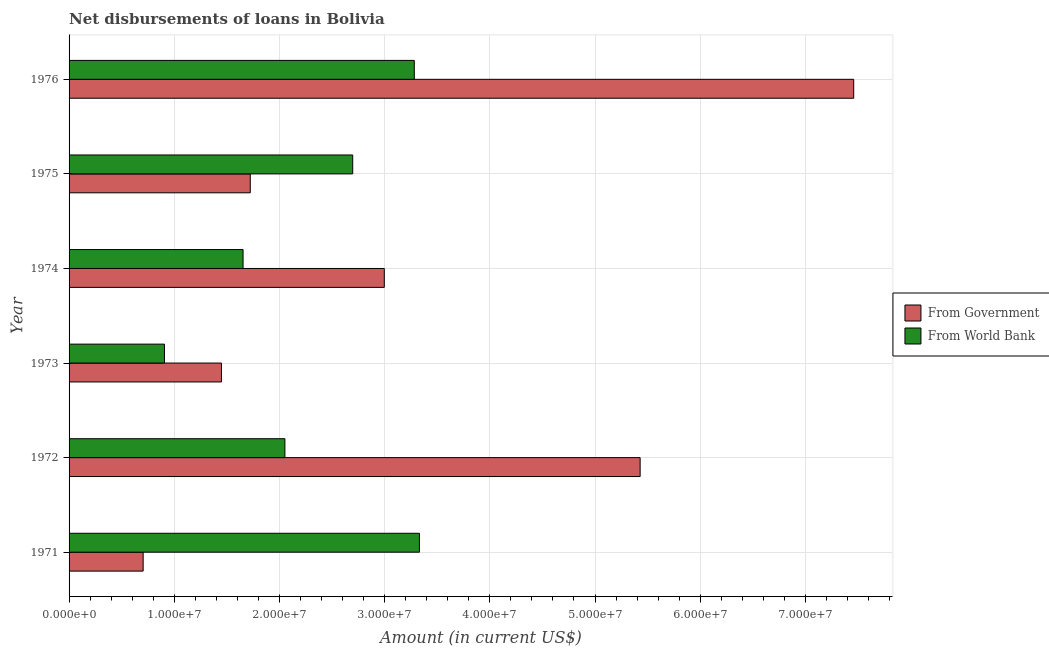How many groups of bars are there?
Make the answer very short. 6. How many bars are there on the 2nd tick from the bottom?
Your answer should be very brief. 2. What is the label of the 4th group of bars from the top?
Make the answer very short. 1973. In how many cases, is the number of bars for a given year not equal to the number of legend labels?
Your response must be concise. 0. What is the net disbursements of loan from world bank in 1973?
Your answer should be very brief. 9.07e+06. Across all years, what is the maximum net disbursements of loan from world bank?
Your answer should be very brief. 3.33e+07. Across all years, what is the minimum net disbursements of loan from world bank?
Keep it short and to the point. 9.07e+06. In which year was the net disbursements of loan from government maximum?
Provide a short and direct response. 1976. In which year was the net disbursements of loan from government minimum?
Provide a short and direct response. 1971. What is the total net disbursements of loan from world bank in the graph?
Give a very brief answer. 1.39e+08. What is the difference between the net disbursements of loan from world bank in 1973 and that in 1974?
Give a very brief answer. -7.47e+06. What is the difference between the net disbursements of loan from government in 1972 and the net disbursements of loan from world bank in 1971?
Keep it short and to the point. 2.10e+07. What is the average net disbursements of loan from world bank per year?
Your response must be concise. 2.32e+07. In the year 1975, what is the difference between the net disbursements of loan from world bank and net disbursements of loan from government?
Keep it short and to the point. 9.74e+06. In how many years, is the net disbursements of loan from government greater than 6000000 US$?
Make the answer very short. 6. What is the ratio of the net disbursements of loan from government in 1971 to that in 1972?
Make the answer very short. 0.13. Is the net disbursements of loan from world bank in 1971 less than that in 1974?
Offer a very short reply. No. Is the difference between the net disbursements of loan from world bank in 1973 and 1976 greater than the difference between the net disbursements of loan from government in 1973 and 1976?
Make the answer very short. Yes. What is the difference between the highest and the second highest net disbursements of loan from world bank?
Give a very brief answer. 4.87e+05. What is the difference between the highest and the lowest net disbursements of loan from world bank?
Your answer should be very brief. 2.42e+07. In how many years, is the net disbursements of loan from government greater than the average net disbursements of loan from government taken over all years?
Your response must be concise. 2. Is the sum of the net disbursements of loan from government in 1971 and 1973 greater than the maximum net disbursements of loan from world bank across all years?
Provide a succinct answer. No. What does the 2nd bar from the top in 1971 represents?
Offer a terse response. From Government. What does the 1st bar from the bottom in 1976 represents?
Keep it short and to the point. From Government. How many bars are there?
Provide a succinct answer. 12. Are all the bars in the graph horizontal?
Keep it short and to the point. Yes. What is the difference between two consecutive major ticks on the X-axis?
Your response must be concise. 1.00e+07. Are the values on the major ticks of X-axis written in scientific E-notation?
Provide a short and direct response. Yes. Where does the legend appear in the graph?
Provide a short and direct response. Center right. How many legend labels are there?
Offer a very short reply. 2. What is the title of the graph?
Your response must be concise. Net disbursements of loans in Bolivia. What is the Amount (in current US$) of From Government in 1971?
Your answer should be very brief. 7.04e+06. What is the Amount (in current US$) of From World Bank in 1971?
Offer a very short reply. 3.33e+07. What is the Amount (in current US$) in From Government in 1972?
Provide a succinct answer. 5.43e+07. What is the Amount (in current US$) in From World Bank in 1972?
Ensure brevity in your answer.  2.05e+07. What is the Amount (in current US$) of From Government in 1973?
Your response must be concise. 1.45e+07. What is the Amount (in current US$) in From World Bank in 1973?
Your response must be concise. 9.07e+06. What is the Amount (in current US$) in From Government in 1974?
Your answer should be compact. 3.00e+07. What is the Amount (in current US$) in From World Bank in 1974?
Provide a succinct answer. 1.65e+07. What is the Amount (in current US$) of From Government in 1975?
Provide a short and direct response. 1.72e+07. What is the Amount (in current US$) of From World Bank in 1975?
Make the answer very short. 2.70e+07. What is the Amount (in current US$) of From Government in 1976?
Keep it short and to the point. 7.46e+07. What is the Amount (in current US$) of From World Bank in 1976?
Ensure brevity in your answer.  3.28e+07. Across all years, what is the maximum Amount (in current US$) of From Government?
Keep it short and to the point. 7.46e+07. Across all years, what is the maximum Amount (in current US$) in From World Bank?
Give a very brief answer. 3.33e+07. Across all years, what is the minimum Amount (in current US$) of From Government?
Offer a terse response. 7.04e+06. Across all years, what is the minimum Amount (in current US$) of From World Bank?
Your answer should be compact. 9.07e+06. What is the total Amount (in current US$) in From Government in the graph?
Keep it short and to the point. 1.98e+08. What is the total Amount (in current US$) in From World Bank in the graph?
Keep it short and to the point. 1.39e+08. What is the difference between the Amount (in current US$) of From Government in 1971 and that in 1972?
Make the answer very short. -4.72e+07. What is the difference between the Amount (in current US$) in From World Bank in 1971 and that in 1972?
Make the answer very short. 1.28e+07. What is the difference between the Amount (in current US$) in From Government in 1971 and that in 1973?
Offer a terse response. -7.44e+06. What is the difference between the Amount (in current US$) in From World Bank in 1971 and that in 1973?
Your response must be concise. 2.42e+07. What is the difference between the Amount (in current US$) in From Government in 1971 and that in 1974?
Your answer should be compact. -2.29e+07. What is the difference between the Amount (in current US$) of From World Bank in 1971 and that in 1974?
Provide a succinct answer. 1.68e+07. What is the difference between the Amount (in current US$) in From Government in 1971 and that in 1975?
Ensure brevity in your answer.  -1.02e+07. What is the difference between the Amount (in current US$) in From World Bank in 1971 and that in 1975?
Ensure brevity in your answer.  6.34e+06. What is the difference between the Amount (in current US$) in From Government in 1971 and that in 1976?
Provide a succinct answer. -6.76e+07. What is the difference between the Amount (in current US$) in From World Bank in 1971 and that in 1976?
Offer a terse response. 4.87e+05. What is the difference between the Amount (in current US$) of From Government in 1972 and that in 1973?
Provide a short and direct response. 3.98e+07. What is the difference between the Amount (in current US$) in From World Bank in 1972 and that in 1973?
Your answer should be compact. 1.14e+07. What is the difference between the Amount (in current US$) of From Government in 1972 and that in 1974?
Make the answer very short. 2.43e+07. What is the difference between the Amount (in current US$) of From World Bank in 1972 and that in 1974?
Your answer should be compact. 3.98e+06. What is the difference between the Amount (in current US$) of From Government in 1972 and that in 1975?
Provide a short and direct response. 3.71e+07. What is the difference between the Amount (in current US$) in From World Bank in 1972 and that in 1975?
Make the answer very short. -6.45e+06. What is the difference between the Amount (in current US$) in From Government in 1972 and that in 1976?
Ensure brevity in your answer.  -2.03e+07. What is the difference between the Amount (in current US$) of From World Bank in 1972 and that in 1976?
Make the answer very short. -1.23e+07. What is the difference between the Amount (in current US$) of From Government in 1973 and that in 1974?
Your answer should be compact. -1.55e+07. What is the difference between the Amount (in current US$) in From World Bank in 1973 and that in 1974?
Offer a terse response. -7.47e+06. What is the difference between the Amount (in current US$) in From Government in 1973 and that in 1975?
Your answer should be very brief. -2.74e+06. What is the difference between the Amount (in current US$) in From World Bank in 1973 and that in 1975?
Offer a terse response. -1.79e+07. What is the difference between the Amount (in current US$) of From Government in 1973 and that in 1976?
Your answer should be very brief. -6.01e+07. What is the difference between the Amount (in current US$) of From World Bank in 1973 and that in 1976?
Ensure brevity in your answer.  -2.38e+07. What is the difference between the Amount (in current US$) in From Government in 1974 and that in 1975?
Make the answer very short. 1.27e+07. What is the difference between the Amount (in current US$) in From World Bank in 1974 and that in 1975?
Keep it short and to the point. -1.04e+07. What is the difference between the Amount (in current US$) in From Government in 1974 and that in 1976?
Offer a very short reply. -4.46e+07. What is the difference between the Amount (in current US$) of From World Bank in 1974 and that in 1976?
Your answer should be very brief. -1.63e+07. What is the difference between the Amount (in current US$) in From Government in 1975 and that in 1976?
Offer a terse response. -5.74e+07. What is the difference between the Amount (in current US$) in From World Bank in 1975 and that in 1976?
Your answer should be compact. -5.85e+06. What is the difference between the Amount (in current US$) of From Government in 1971 and the Amount (in current US$) of From World Bank in 1972?
Offer a very short reply. -1.35e+07. What is the difference between the Amount (in current US$) in From Government in 1971 and the Amount (in current US$) in From World Bank in 1973?
Ensure brevity in your answer.  -2.03e+06. What is the difference between the Amount (in current US$) in From Government in 1971 and the Amount (in current US$) in From World Bank in 1974?
Your answer should be compact. -9.50e+06. What is the difference between the Amount (in current US$) of From Government in 1971 and the Amount (in current US$) of From World Bank in 1975?
Your answer should be very brief. -1.99e+07. What is the difference between the Amount (in current US$) in From Government in 1971 and the Amount (in current US$) in From World Bank in 1976?
Your response must be concise. -2.58e+07. What is the difference between the Amount (in current US$) in From Government in 1972 and the Amount (in current US$) in From World Bank in 1973?
Offer a terse response. 4.52e+07. What is the difference between the Amount (in current US$) of From Government in 1972 and the Amount (in current US$) of From World Bank in 1974?
Keep it short and to the point. 3.78e+07. What is the difference between the Amount (in current US$) in From Government in 1972 and the Amount (in current US$) in From World Bank in 1975?
Offer a very short reply. 2.73e+07. What is the difference between the Amount (in current US$) of From Government in 1972 and the Amount (in current US$) of From World Bank in 1976?
Offer a terse response. 2.15e+07. What is the difference between the Amount (in current US$) of From Government in 1973 and the Amount (in current US$) of From World Bank in 1974?
Your answer should be very brief. -2.05e+06. What is the difference between the Amount (in current US$) of From Government in 1973 and the Amount (in current US$) of From World Bank in 1975?
Make the answer very short. -1.25e+07. What is the difference between the Amount (in current US$) in From Government in 1973 and the Amount (in current US$) in From World Bank in 1976?
Keep it short and to the point. -1.83e+07. What is the difference between the Amount (in current US$) in From Government in 1974 and the Amount (in current US$) in From World Bank in 1975?
Keep it short and to the point. 3.00e+06. What is the difference between the Amount (in current US$) in From Government in 1974 and the Amount (in current US$) in From World Bank in 1976?
Your answer should be very brief. -2.85e+06. What is the difference between the Amount (in current US$) in From Government in 1975 and the Amount (in current US$) in From World Bank in 1976?
Ensure brevity in your answer.  -1.56e+07. What is the average Amount (in current US$) of From Government per year?
Make the answer very short. 3.29e+07. What is the average Amount (in current US$) of From World Bank per year?
Offer a very short reply. 2.32e+07. In the year 1971, what is the difference between the Amount (in current US$) of From Government and Amount (in current US$) of From World Bank?
Your response must be concise. -2.63e+07. In the year 1972, what is the difference between the Amount (in current US$) of From Government and Amount (in current US$) of From World Bank?
Provide a short and direct response. 3.38e+07. In the year 1973, what is the difference between the Amount (in current US$) of From Government and Amount (in current US$) of From World Bank?
Give a very brief answer. 5.42e+06. In the year 1974, what is the difference between the Amount (in current US$) of From Government and Amount (in current US$) of From World Bank?
Offer a very short reply. 1.34e+07. In the year 1975, what is the difference between the Amount (in current US$) of From Government and Amount (in current US$) of From World Bank?
Make the answer very short. -9.74e+06. In the year 1976, what is the difference between the Amount (in current US$) in From Government and Amount (in current US$) in From World Bank?
Keep it short and to the point. 4.18e+07. What is the ratio of the Amount (in current US$) of From Government in 1971 to that in 1972?
Your answer should be compact. 0.13. What is the ratio of the Amount (in current US$) of From World Bank in 1971 to that in 1972?
Keep it short and to the point. 1.62. What is the ratio of the Amount (in current US$) of From Government in 1971 to that in 1973?
Offer a terse response. 0.49. What is the ratio of the Amount (in current US$) in From World Bank in 1971 to that in 1973?
Your response must be concise. 3.67. What is the ratio of the Amount (in current US$) in From Government in 1971 to that in 1974?
Keep it short and to the point. 0.23. What is the ratio of the Amount (in current US$) of From World Bank in 1971 to that in 1974?
Make the answer very short. 2.01. What is the ratio of the Amount (in current US$) in From Government in 1971 to that in 1975?
Your answer should be compact. 0.41. What is the ratio of the Amount (in current US$) of From World Bank in 1971 to that in 1975?
Provide a succinct answer. 1.24. What is the ratio of the Amount (in current US$) of From Government in 1971 to that in 1976?
Your answer should be very brief. 0.09. What is the ratio of the Amount (in current US$) in From World Bank in 1971 to that in 1976?
Your answer should be compact. 1.01. What is the ratio of the Amount (in current US$) in From Government in 1972 to that in 1973?
Offer a terse response. 3.75. What is the ratio of the Amount (in current US$) of From World Bank in 1972 to that in 1973?
Your answer should be compact. 2.26. What is the ratio of the Amount (in current US$) in From Government in 1972 to that in 1974?
Ensure brevity in your answer.  1.81. What is the ratio of the Amount (in current US$) of From World Bank in 1972 to that in 1974?
Offer a terse response. 1.24. What is the ratio of the Amount (in current US$) of From Government in 1972 to that in 1975?
Provide a short and direct response. 3.15. What is the ratio of the Amount (in current US$) in From World Bank in 1972 to that in 1975?
Your answer should be very brief. 0.76. What is the ratio of the Amount (in current US$) in From Government in 1972 to that in 1976?
Provide a succinct answer. 0.73. What is the ratio of the Amount (in current US$) of From World Bank in 1972 to that in 1976?
Your response must be concise. 0.63. What is the ratio of the Amount (in current US$) in From Government in 1973 to that in 1974?
Provide a short and direct response. 0.48. What is the ratio of the Amount (in current US$) of From World Bank in 1973 to that in 1974?
Keep it short and to the point. 0.55. What is the ratio of the Amount (in current US$) in From Government in 1973 to that in 1975?
Keep it short and to the point. 0.84. What is the ratio of the Amount (in current US$) in From World Bank in 1973 to that in 1975?
Offer a very short reply. 0.34. What is the ratio of the Amount (in current US$) of From Government in 1973 to that in 1976?
Your answer should be compact. 0.19. What is the ratio of the Amount (in current US$) of From World Bank in 1973 to that in 1976?
Your response must be concise. 0.28. What is the ratio of the Amount (in current US$) of From Government in 1974 to that in 1975?
Offer a very short reply. 1.74. What is the ratio of the Amount (in current US$) in From World Bank in 1974 to that in 1975?
Offer a very short reply. 0.61. What is the ratio of the Amount (in current US$) of From Government in 1974 to that in 1976?
Your answer should be very brief. 0.4. What is the ratio of the Amount (in current US$) in From World Bank in 1974 to that in 1976?
Your response must be concise. 0.5. What is the ratio of the Amount (in current US$) in From Government in 1975 to that in 1976?
Offer a terse response. 0.23. What is the ratio of the Amount (in current US$) in From World Bank in 1975 to that in 1976?
Your response must be concise. 0.82. What is the difference between the highest and the second highest Amount (in current US$) in From Government?
Offer a terse response. 2.03e+07. What is the difference between the highest and the second highest Amount (in current US$) of From World Bank?
Ensure brevity in your answer.  4.87e+05. What is the difference between the highest and the lowest Amount (in current US$) of From Government?
Provide a succinct answer. 6.76e+07. What is the difference between the highest and the lowest Amount (in current US$) in From World Bank?
Make the answer very short. 2.42e+07. 